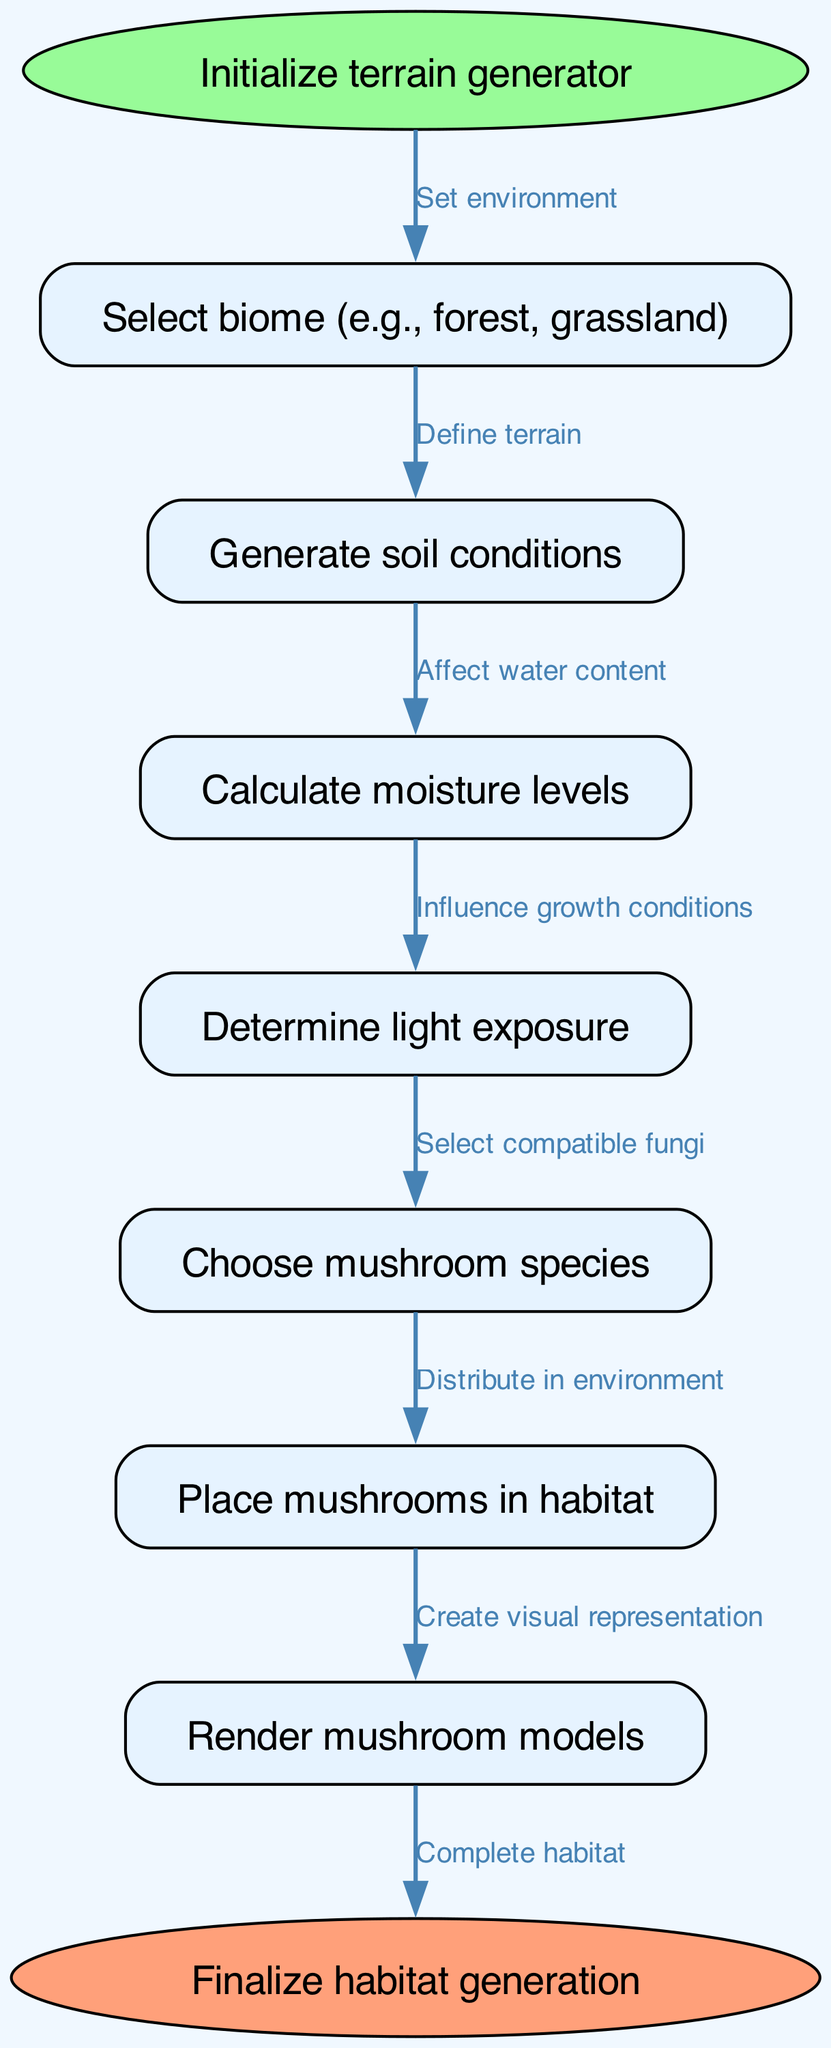What is the starting node of the flowchart? The flowchart begins at the node labeled "Initialize terrain generator," which is the first step in generating the mushroom habitat.
Answer: Initialize terrain generator How many total nodes are present in the diagram? By counting the nodes listed in the diagram, we can see there are nine nodes in total: start, biome, soil, moisture, light, species, placement, render, and end.
Answer: Nine What type of mushroom species is chosen based on light exposure? The diagram indicates that the "Choose mushroom species" step is dependent on the "Determine light exposure" step, specifying that this selection is based on light conditions.
Answer: Compatible fungi Which node comes after calculating moisture levels? According to the flowchart, after "Calculate moisture levels," the next step is "Determine light exposure," indicating the sequential process of habitat generation.
Answer: Determine light exposure How many edges connect the nodes in the flowchart? The edges represent the directional connections between the nodes and based on the provided information there are eight edges connecting the nodes.
Answer: Eight What is the function of the "Render mushroom models" node? The node "Render mushroom models" is responsible for creating a visual representation of the mushrooms placed in the habitat based on previous inputs in the flowchart.
Answer: Create visual representation In which part of the flowchart are environmental conditions defined? Environmental conditions are defined in the "Select biome" step, which is the second step following the initialization of the terrain generator.
Answer: Select biome What is the relationship between "Generate soil conditions" and "Calculate moisture levels"? The "Generate soil conditions" node affects "Calculate moisture levels," indicating that the type of soil generated has an impact on the moisture available in the habitat.
Answer: Affect water content What happens at the end of the flowchart process? At the end of the diagram, the process concludes with the node labeled "Finalize habitat generation," signifying the completion of the procedural generation for the mushroom habitat.
Answer: Finalize habitat generation 